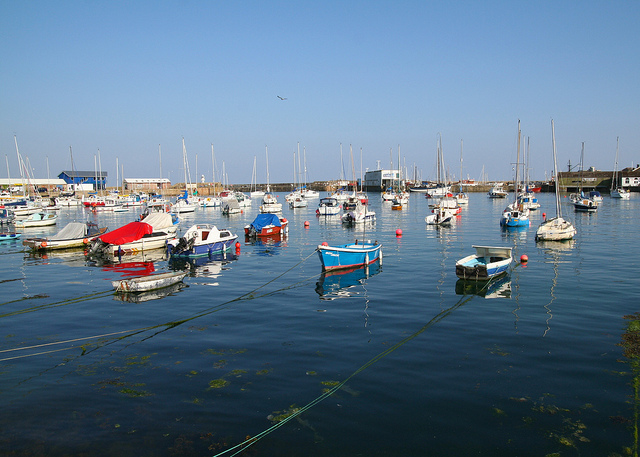How many boats are in the picture? There are numerous boats of various sizes and colors moored in the calm waters of this harbor, creating a serene and picturesque scene. 